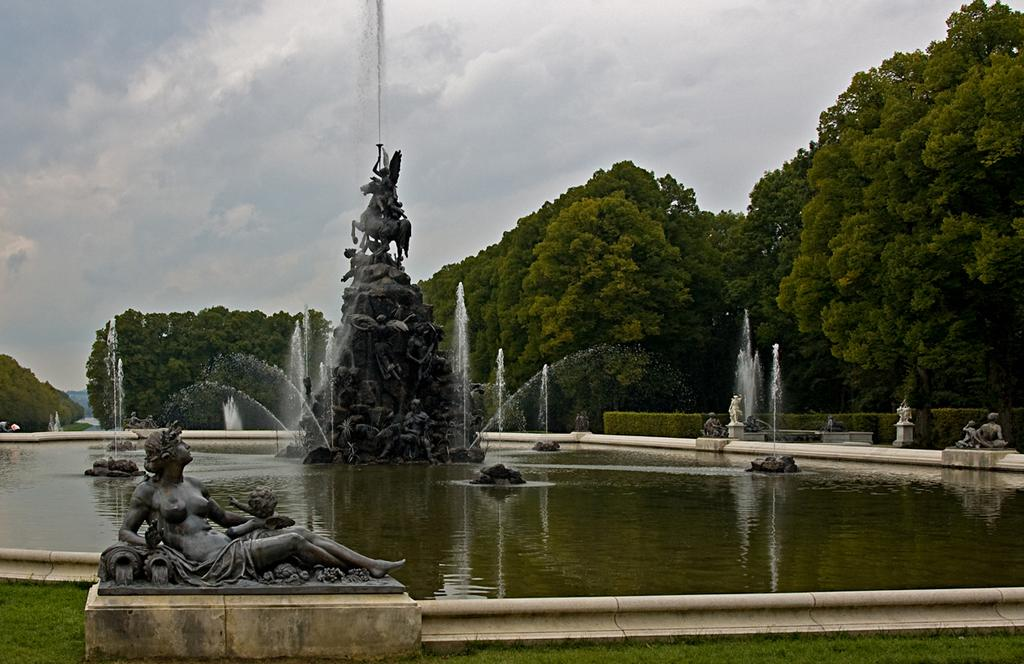What is the main subject in the center of the image? There is a statue and a fountain in the center of the image. What else can be seen on the left side of the image? There is a sculpture on the left side of the image. What type of natural elements are visible in the background of the image? There are trees in the background of the image. What is visible in the sky in the background of the image? The sky is visible in the background of the image. What type of badge is the zebra wearing in the image? There is no zebra present in the image, and therefore no badge can be observed. 